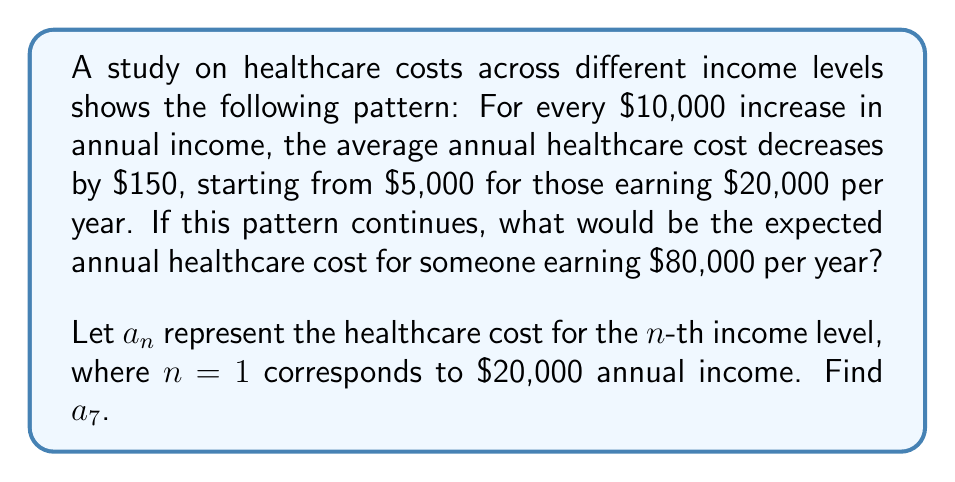Provide a solution to this math problem. Let's approach this step-by-step:

1) First, we need to identify the sequence pattern:
   - Initial term (a₁): $5,000 for $20,000 income
   - Common difference: -$150 for every $10,000 increase in income

2) We can express this as an arithmetic sequence:
   $$a_n = a_1 + (n-1)d$$
   Where:
   $a_1 = 5000$
   $d = -150$

3) Now, we need to find $a_7$, which corresponds to $80,000 income:
   $$a_7 = 5000 + (7-1)(-150)$$

4) Simplify:
   $$a_7 = 5000 + 6(-150)$$
   $$a_7 = 5000 - 900$$

5) Calculate the final result:
   $$a_7 = 4100$$

Therefore, the expected annual healthcare cost for someone earning $80,000 per year would be $4,100.
Answer: $4,100 